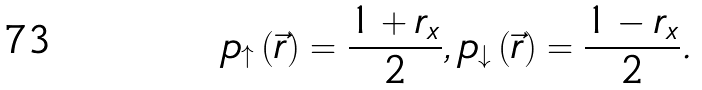<formula> <loc_0><loc_0><loc_500><loc_500>p _ { \uparrow } \left ( \vec { r } \right ) = \frac { 1 + r _ { x } } { 2 } , p _ { \downarrow } \left ( \vec { r } \right ) = \frac { 1 - r _ { x } } { 2 } .</formula> 